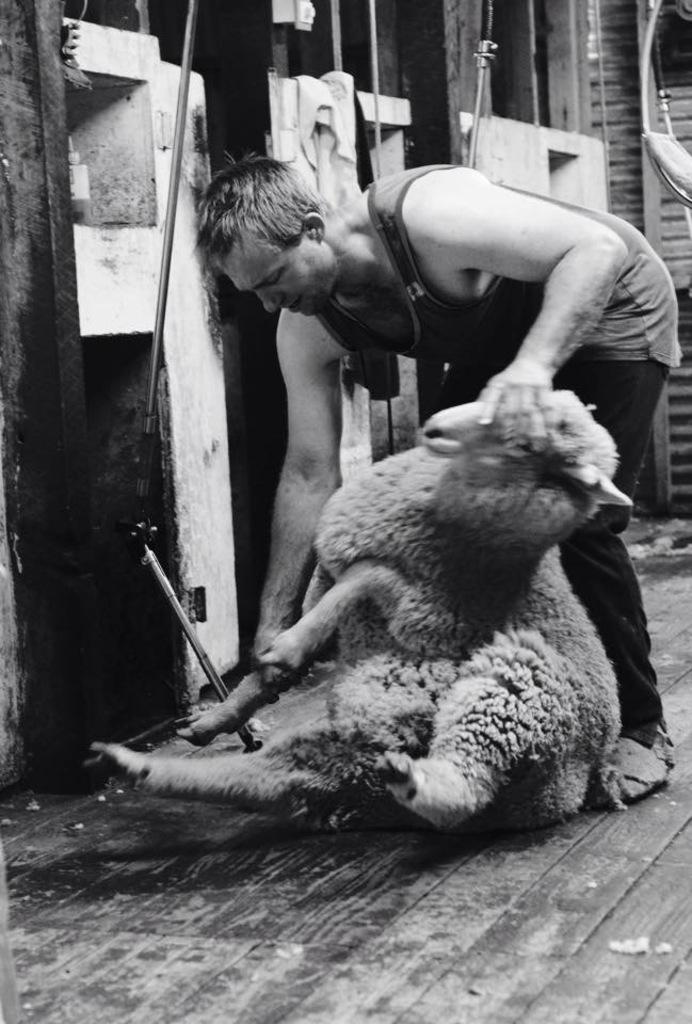What is the color scheme of the image? The image is black and white. What is the person in the image holding? The person is holding a sheep in the image. What can be seen in the background of the image? There are metal rods, walls, and a few other objects in the background of the image. What type of polish is being applied to the sheep in the image? There is no polish being applied to the sheep in the image, as it is a black and white photograph and the focus is on the person holding the sheep. 